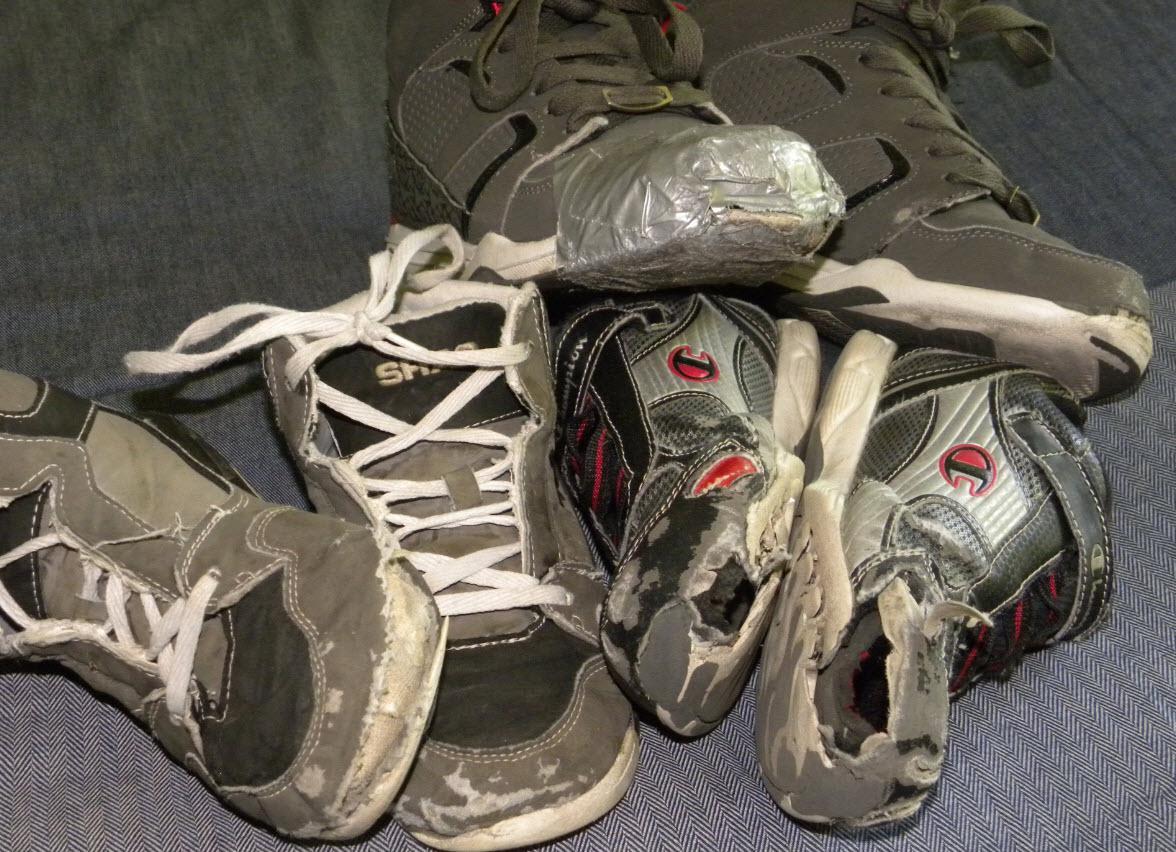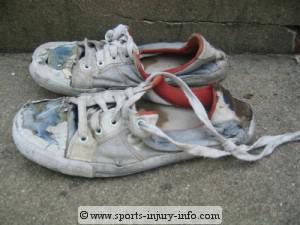The first image is the image on the left, the second image is the image on the right. Evaluate the accuracy of this statement regarding the images: "Some sneakers are brand new and some are not.". Is it true? Answer yes or no. No. The first image is the image on the left, the second image is the image on the right. Evaluate the accuracy of this statement regarding the images: "There are at least four pairs of shoes.". Is it true? Answer yes or no. Yes. 